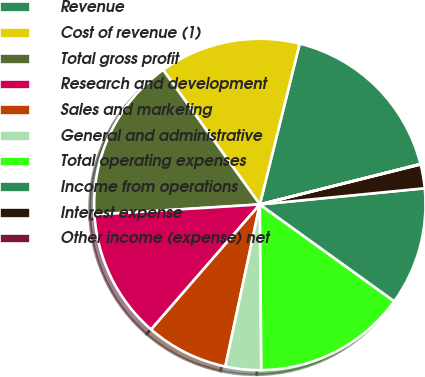Convert chart to OTSL. <chart><loc_0><loc_0><loc_500><loc_500><pie_chart><fcel>Revenue<fcel>Cost of revenue (1)<fcel>Total gross profit<fcel>Research and development<fcel>Sales and marketing<fcel>General and administrative<fcel>Total operating expenses<fcel>Income from operations<fcel>Interest expense<fcel>Other income (expense) net<nl><fcel>17.21%<fcel>13.78%<fcel>16.06%<fcel>12.63%<fcel>8.05%<fcel>3.48%<fcel>14.92%<fcel>11.49%<fcel>2.33%<fcel>0.04%<nl></chart> 